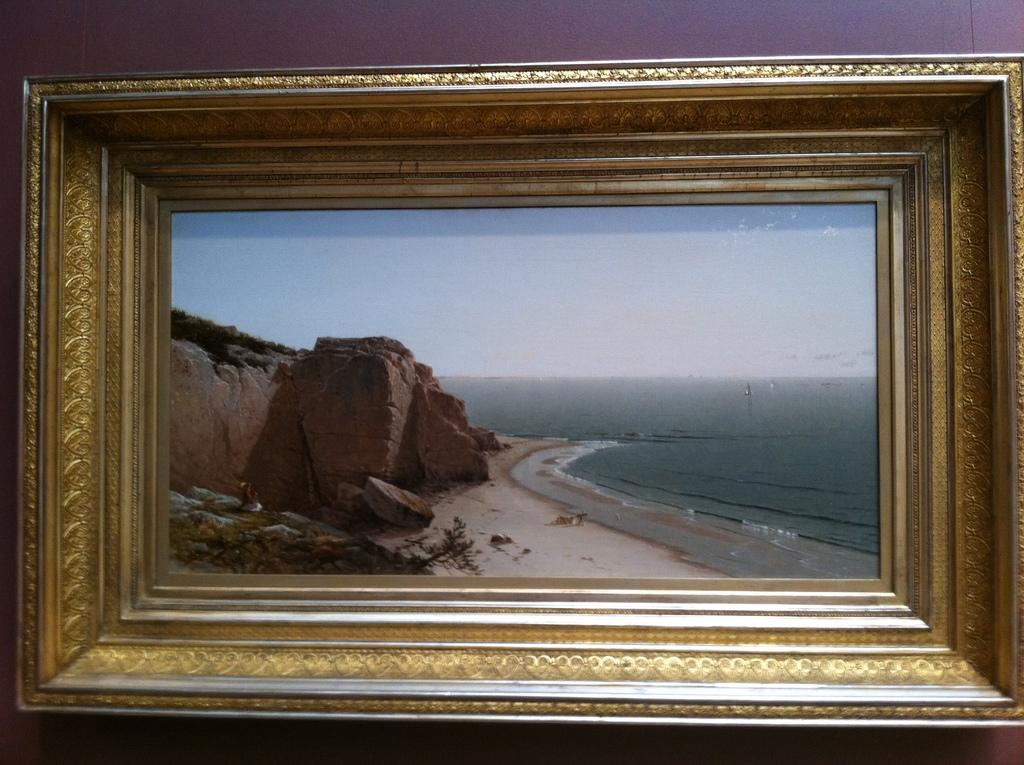What is the color of the wall on which the picture is hung? The wall is purple. Is the picture in a frame? Yes, the picture is framed. What elements can be seen in the picture? The picture contains rocks, water, and sky. What type of meeting is taking place in the picture? There is no meeting depicted in the image; it contains rocks, water, and sky. How much wealth is visible in the picture? There is no indication of wealth in the image, as it features a picture with rocks, water, and sky. 